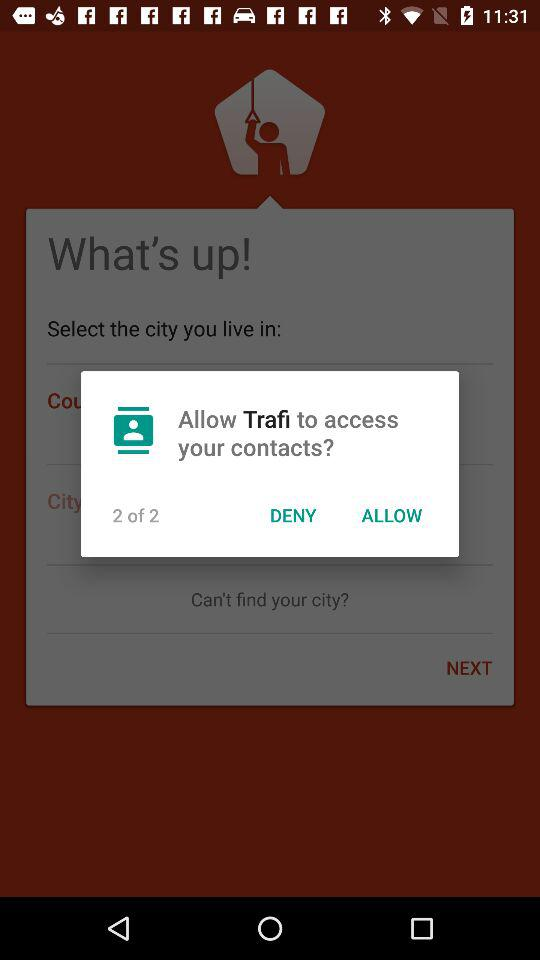How many contacts does the user have?
When the provided information is insufficient, respond with <no answer>. <no answer> 